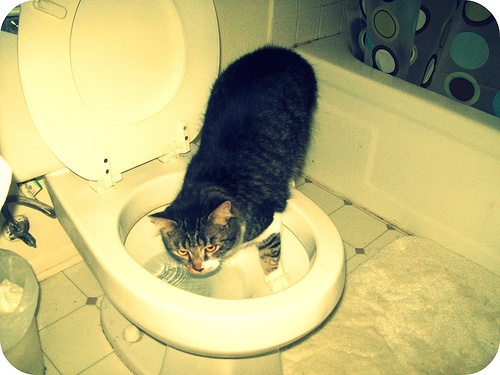Describe the objects in this image and their specific colors. I can see toilet in white, khaki, lightyellow, and tan tones and cat in white, black, gray, and tan tones in this image. 